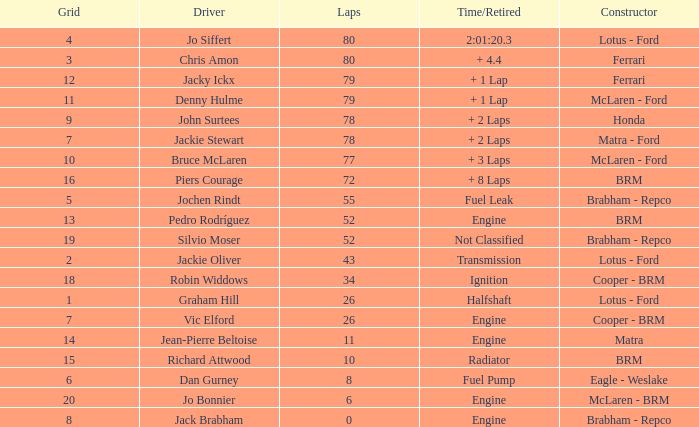When the driver richard attwood has a constructor of brm, what is the number of laps? 10.0. 